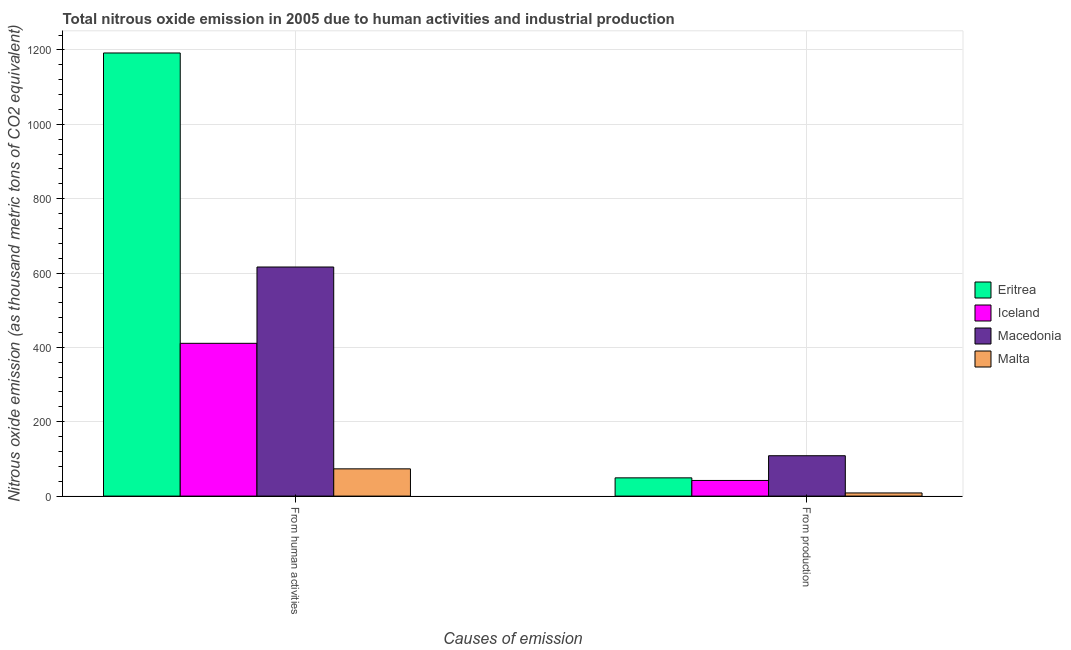How many groups of bars are there?
Ensure brevity in your answer.  2. Are the number of bars on each tick of the X-axis equal?
Your answer should be very brief. Yes. How many bars are there on the 2nd tick from the right?
Your answer should be compact. 4. What is the label of the 2nd group of bars from the left?
Provide a short and direct response. From production. What is the amount of emissions generated from industries in Eritrea?
Keep it short and to the point. 49.1. Across all countries, what is the maximum amount of emissions generated from industries?
Offer a terse response. 108.6. Across all countries, what is the minimum amount of emissions from human activities?
Make the answer very short. 73.3. In which country was the amount of emissions from human activities maximum?
Provide a succinct answer. Eritrea. In which country was the amount of emissions from human activities minimum?
Provide a short and direct response. Malta. What is the total amount of emissions from human activities in the graph?
Give a very brief answer. 2292. What is the difference between the amount of emissions from human activities in Macedonia and that in Malta?
Give a very brief answer. 542.8. What is the difference between the amount of emissions from human activities in Macedonia and the amount of emissions generated from industries in Eritrea?
Offer a terse response. 567. What is the average amount of emissions from human activities per country?
Offer a very short reply. 573. What is the difference between the amount of emissions generated from industries and amount of emissions from human activities in Eritrea?
Your answer should be very brief. -1142.6. In how many countries, is the amount of emissions from human activities greater than 520 thousand metric tons?
Ensure brevity in your answer.  2. What is the ratio of the amount of emissions generated from industries in Malta to that in Eritrea?
Your answer should be very brief. 0.17. Is the amount of emissions generated from industries in Iceland less than that in Eritrea?
Your answer should be compact. Yes. What does the 3rd bar from the left in From production represents?
Offer a very short reply. Macedonia. What does the 2nd bar from the right in From human activities represents?
Your response must be concise. Macedonia. Are all the bars in the graph horizontal?
Your response must be concise. No. Does the graph contain grids?
Your response must be concise. Yes. Where does the legend appear in the graph?
Give a very brief answer. Center right. How are the legend labels stacked?
Keep it short and to the point. Vertical. What is the title of the graph?
Keep it short and to the point. Total nitrous oxide emission in 2005 due to human activities and industrial production. Does "Armenia" appear as one of the legend labels in the graph?
Provide a succinct answer. No. What is the label or title of the X-axis?
Your answer should be very brief. Causes of emission. What is the label or title of the Y-axis?
Keep it short and to the point. Nitrous oxide emission (as thousand metric tons of CO2 equivalent). What is the Nitrous oxide emission (as thousand metric tons of CO2 equivalent) in Eritrea in From human activities?
Provide a succinct answer. 1191.7. What is the Nitrous oxide emission (as thousand metric tons of CO2 equivalent) of Iceland in From human activities?
Provide a succinct answer. 410.9. What is the Nitrous oxide emission (as thousand metric tons of CO2 equivalent) in Macedonia in From human activities?
Your response must be concise. 616.1. What is the Nitrous oxide emission (as thousand metric tons of CO2 equivalent) of Malta in From human activities?
Ensure brevity in your answer.  73.3. What is the Nitrous oxide emission (as thousand metric tons of CO2 equivalent) of Eritrea in From production?
Your answer should be very brief. 49.1. What is the Nitrous oxide emission (as thousand metric tons of CO2 equivalent) of Iceland in From production?
Provide a succinct answer. 42.1. What is the Nitrous oxide emission (as thousand metric tons of CO2 equivalent) of Macedonia in From production?
Provide a short and direct response. 108.6. Across all Causes of emission, what is the maximum Nitrous oxide emission (as thousand metric tons of CO2 equivalent) in Eritrea?
Give a very brief answer. 1191.7. Across all Causes of emission, what is the maximum Nitrous oxide emission (as thousand metric tons of CO2 equivalent) in Iceland?
Offer a terse response. 410.9. Across all Causes of emission, what is the maximum Nitrous oxide emission (as thousand metric tons of CO2 equivalent) in Macedonia?
Offer a very short reply. 616.1. Across all Causes of emission, what is the maximum Nitrous oxide emission (as thousand metric tons of CO2 equivalent) of Malta?
Your response must be concise. 73.3. Across all Causes of emission, what is the minimum Nitrous oxide emission (as thousand metric tons of CO2 equivalent) of Eritrea?
Make the answer very short. 49.1. Across all Causes of emission, what is the minimum Nitrous oxide emission (as thousand metric tons of CO2 equivalent) in Iceland?
Offer a terse response. 42.1. Across all Causes of emission, what is the minimum Nitrous oxide emission (as thousand metric tons of CO2 equivalent) in Macedonia?
Offer a very short reply. 108.6. Across all Causes of emission, what is the minimum Nitrous oxide emission (as thousand metric tons of CO2 equivalent) of Malta?
Your answer should be compact. 8.5. What is the total Nitrous oxide emission (as thousand metric tons of CO2 equivalent) of Eritrea in the graph?
Provide a short and direct response. 1240.8. What is the total Nitrous oxide emission (as thousand metric tons of CO2 equivalent) in Iceland in the graph?
Ensure brevity in your answer.  453. What is the total Nitrous oxide emission (as thousand metric tons of CO2 equivalent) of Macedonia in the graph?
Give a very brief answer. 724.7. What is the total Nitrous oxide emission (as thousand metric tons of CO2 equivalent) in Malta in the graph?
Give a very brief answer. 81.8. What is the difference between the Nitrous oxide emission (as thousand metric tons of CO2 equivalent) in Eritrea in From human activities and that in From production?
Keep it short and to the point. 1142.6. What is the difference between the Nitrous oxide emission (as thousand metric tons of CO2 equivalent) in Iceland in From human activities and that in From production?
Make the answer very short. 368.8. What is the difference between the Nitrous oxide emission (as thousand metric tons of CO2 equivalent) in Macedonia in From human activities and that in From production?
Keep it short and to the point. 507.5. What is the difference between the Nitrous oxide emission (as thousand metric tons of CO2 equivalent) of Malta in From human activities and that in From production?
Your answer should be compact. 64.8. What is the difference between the Nitrous oxide emission (as thousand metric tons of CO2 equivalent) of Eritrea in From human activities and the Nitrous oxide emission (as thousand metric tons of CO2 equivalent) of Iceland in From production?
Your response must be concise. 1149.6. What is the difference between the Nitrous oxide emission (as thousand metric tons of CO2 equivalent) in Eritrea in From human activities and the Nitrous oxide emission (as thousand metric tons of CO2 equivalent) in Macedonia in From production?
Your answer should be very brief. 1083.1. What is the difference between the Nitrous oxide emission (as thousand metric tons of CO2 equivalent) in Eritrea in From human activities and the Nitrous oxide emission (as thousand metric tons of CO2 equivalent) in Malta in From production?
Your answer should be very brief. 1183.2. What is the difference between the Nitrous oxide emission (as thousand metric tons of CO2 equivalent) in Iceland in From human activities and the Nitrous oxide emission (as thousand metric tons of CO2 equivalent) in Macedonia in From production?
Offer a very short reply. 302.3. What is the difference between the Nitrous oxide emission (as thousand metric tons of CO2 equivalent) of Iceland in From human activities and the Nitrous oxide emission (as thousand metric tons of CO2 equivalent) of Malta in From production?
Give a very brief answer. 402.4. What is the difference between the Nitrous oxide emission (as thousand metric tons of CO2 equivalent) in Macedonia in From human activities and the Nitrous oxide emission (as thousand metric tons of CO2 equivalent) in Malta in From production?
Keep it short and to the point. 607.6. What is the average Nitrous oxide emission (as thousand metric tons of CO2 equivalent) of Eritrea per Causes of emission?
Your answer should be very brief. 620.4. What is the average Nitrous oxide emission (as thousand metric tons of CO2 equivalent) in Iceland per Causes of emission?
Keep it short and to the point. 226.5. What is the average Nitrous oxide emission (as thousand metric tons of CO2 equivalent) in Macedonia per Causes of emission?
Your response must be concise. 362.35. What is the average Nitrous oxide emission (as thousand metric tons of CO2 equivalent) in Malta per Causes of emission?
Ensure brevity in your answer.  40.9. What is the difference between the Nitrous oxide emission (as thousand metric tons of CO2 equivalent) of Eritrea and Nitrous oxide emission (as thousand metric tons of CO2 equivalent) of Iceland in From human activities?
Offer a very short reply. 780.8. What is the difference between the Nitrous oxide emission (as thousand metric tons of CO2 equivalent) of Eritrea and Nitrous oxide emission (as thousand metric tons of CO2 equivalent) of Macedonia in From human activities?
Ensure brevity in your answer.  575.6. What is the difference between the Nitrous oxide emission (as thousand metric tons of CO2 equivalent) of Eritrea and Nitrous oxide emission (as thousand metric tons of CO2 equivalent) of Malta in From human activities?
Provide a short and direct response. 1118.4. What is the difference between the Nitrous oxide emission (as thousand metric tons of CO2 equivalent) of Iceland and Nitrous oxide emission (as thousand metric tons of CO2 equivalent) of Macedonia in From human activities?
Your answer should be compact. -205.2. What is the difference between the Nitrous oxide emission (as thousand metric tons of CO2 equivalent) in Iceland and Nitrous oxide emission (as thousand metric tons of CO2 equivalent) in Malta in From human activities?
Your response must be concise. 337.6. What is the difference between the Nitrous oxide emission (as thousand metric tons of CO2 equivalent) of Macedonia and Nitrous oxide emission (as thousand metric tons of CO2 equivalent) of Malta in From human activities?
Your response must be concise. 542.8. What is the difference between the Nitrous oxide emission (as thousand metric tons of CO2 equivalent) of Eritrea and Nitrous oxide emission (as thousand metric tons of CO2 equivalent) of Iceland in From production?
Provide a short and direct response. 7. What is the difference between the Nitrous oxide emission (as thousand metric tons of CO2 equivalent) in Eritrea and Nitrous oxide emission (as thousand metric tons of CO2 equivalent) in Macedonia in From production?
Make the answer very short. -59.5. What is the difference between the Nitrous oxide emission (as thousand metric tons of CO2 equivalent) of Eritrea and Nitrous oxide emission (as thousand metric tons of CO2 equivalent) of Malta in From production?
Offer a very short reply. 40.6. What is the difference between the Nitrous oxide emission (as thousand metric tons of CO2 equivalent) in Iceland and Nitrous oxide emission (as thousand metric tons of CO2 equivalent) in Macedonia in From production?
Keep it short and to the point. -66.5. What is the difference between the Nitrous oxide emission (as thousand metric tons of CO2 equivalent) of Iceland and Nitrous oxide emission (as thousand metric tons of CO2 equivalent) of Malta in From production?
Give a very brief answer. 33.6. What is the difference between the Nitrous oxide emission (as thousand metric tons of CO2 equivalent) in Macedonia and Nitrous oxide emission (as thousand metric tons of CO2 equivalent) in Malta in From production?
Keep it short and to the point. 100.1. What is the ratio of the Nitrous oxide emission (as thousand metric tons of CO2 equivalent) in Eritrea in From human activities to that in From production?
Ensure brevity in your answer.  24.27. What is the ratio of the Nitrous oxide emission (as thousand metric tons of CO2 equivalent) of Iceland in From human activities to that in From production?
Keep it short and to the point. 9.76. What is the ratio of the Nitrous oxide emission (as thousand metric tons of CO2 equivalent) of Macedonia in From human activities to that in From production?
Your response must be concise. 5.67. What is the ratio of the Nitrous oxide emission (as thousand metric tons of CO2 equivalent) of Malta in From human activities to that in From production?
Provide a short and direct response. 8.62. What is the difference between the highest and the second highest Nitrous oxide emission (as thousand metric tons of CO2 equivalent) of Eritrea?
Give a very brief answer. 1142.6. What is the difference between the highest and the second highest Nitrous oxide emission (as thousand metric tons of CO2 equivalent) of Iceland?
Your answer should be very brief. 368.8. What is the difference between the highest and the second highest Nitrous oxide emission (as thousand metric tons of CO2 equivalent) of Macedonia?
Your answer should be compact. 507.5. What is the difference between the highest and the second highest Nitrous oxide emission (as thousand metric tons of CO2 equivalent) in Malta?
Give a very brief answer. 64.8. What is the difference between the highest and the lowest Nitrous oxide emission (as thousand metric tons of CO2 equivalent) of Eritrea?
Provide a short and direct response. 1142.6. What is the difference between the highest and the lowest Nitrous oxide emission (as thousand metric tons of CO2 equivalent) in Iceland?
Provide a succinct answer. 368.8. What is the difference between the highest and the lowest Nitrous oxide emission (as thousand metric tons of CO2 equivalent) in Macedonia?
Your answer should be compact. 507.5. What is the difference between the highest and the lowest Nitrous oxide emission (as thousand metric tons of CO2 equivalent) of Malta?
Provide a succinct answer. 64.8. 